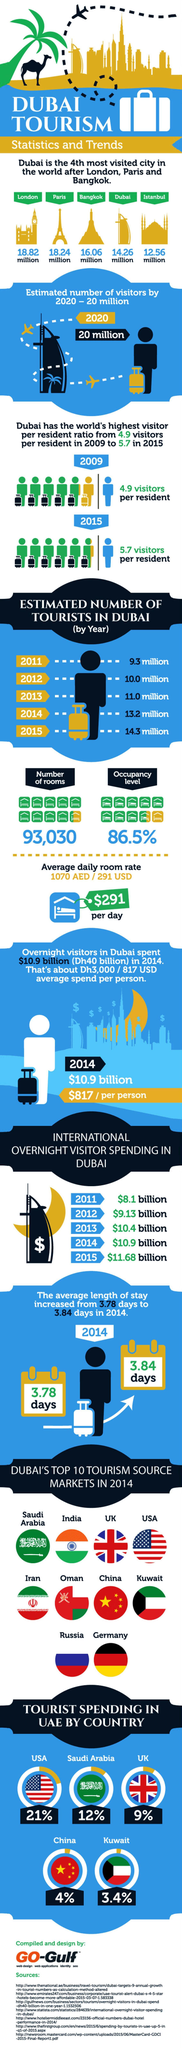What is the percentage of money spent by Saudi Arabia on tourists?
Answer the question with a short phrase. 12% Which is the 3rd most visited city in the world? Bangkok What is the international overnight visitor spending in Dubai in the year 2011 and 2012, taken together? $17.23 billion What is the percentage of money spent by Saudi Arabia and the UK on tourists, taken together? 21% What is the estimated number of tourists in 2011 and 2012, taken together? 19.3 million 